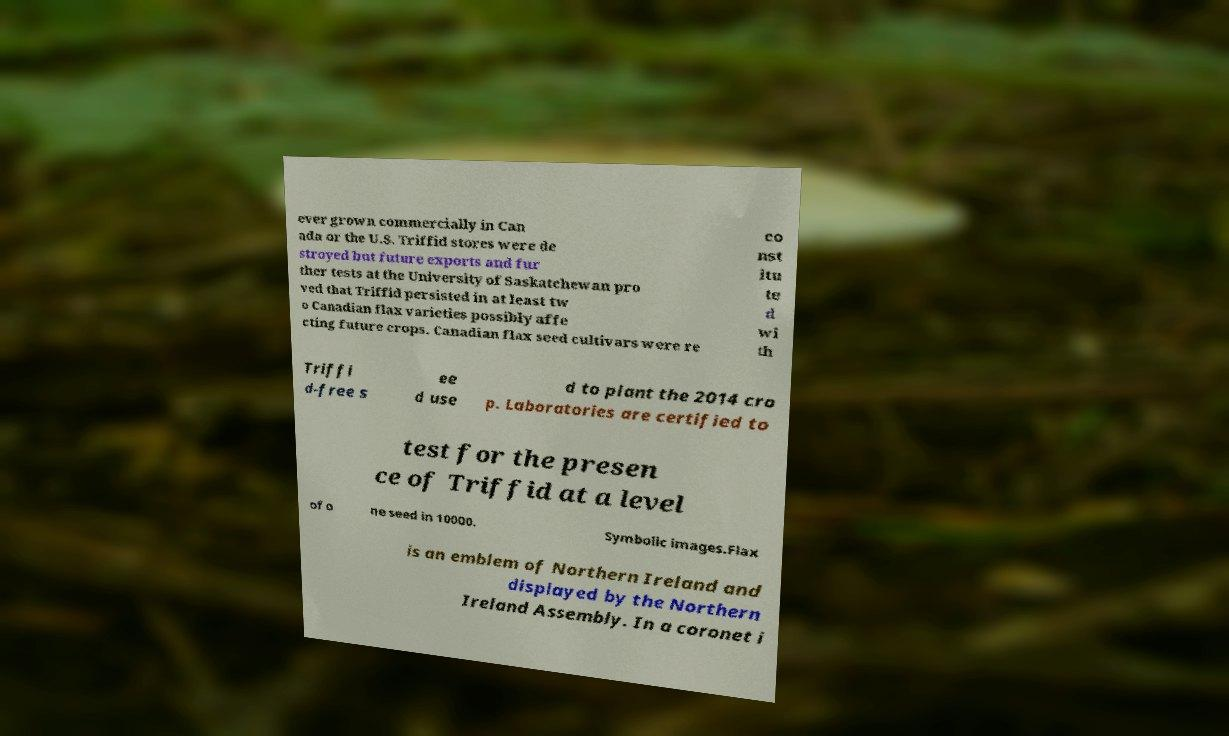Could you extract and type out the text from this image? ever grown commercially in Can ada or the U.S. Triffid stores were de stroyed but future exports and fur ther tests at the University of Saskatchewan pro ved that Triffid persisted in at least tw o Canadian flax varieties possibly affe cting future crops. Canadian flax seed cultivars were re co nst itu te d wi th Triffi d-free s ee d use d to plant the 2014 cro p. Laboratories are certified to test for the presen ce of Triffid at a level of o ne seed in 10000. Symbolic images.Flax is an emblem of Northern Ireland and displayed by the Northern Ireland Assembly. In a coronet i 